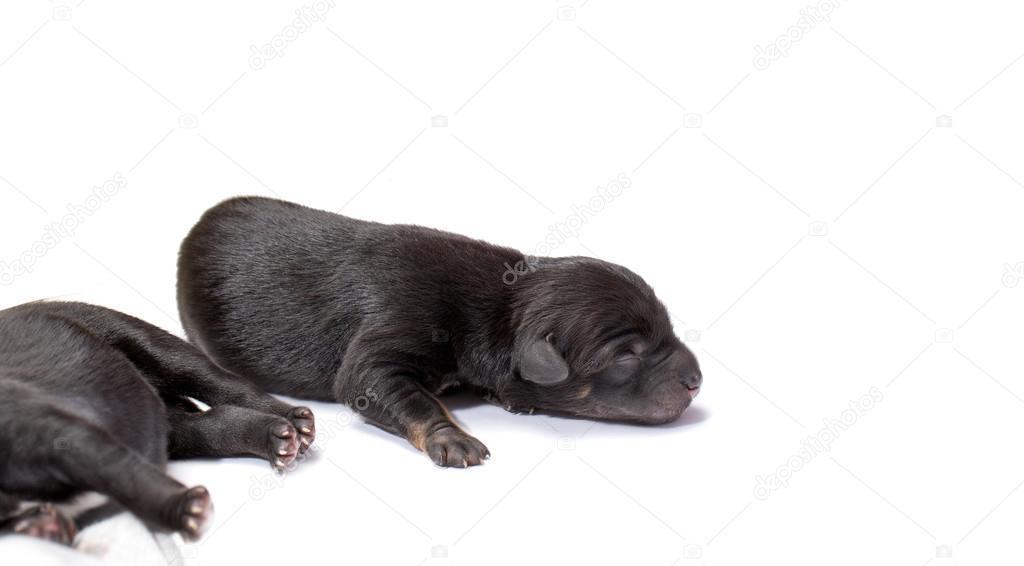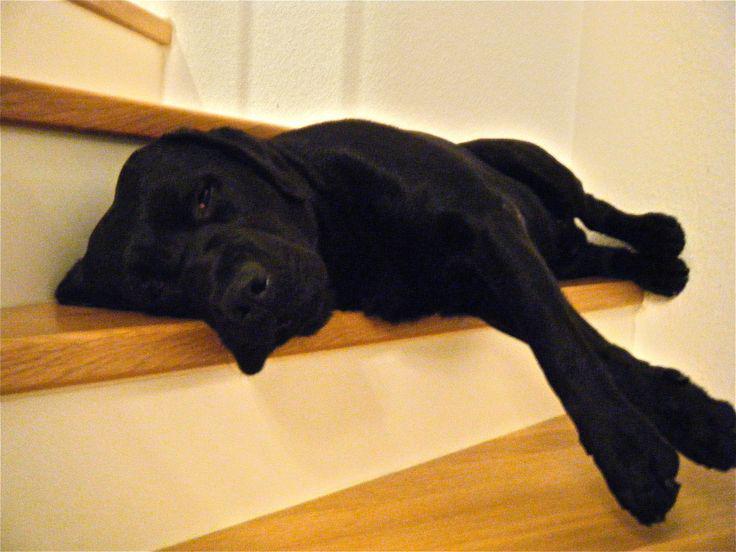The first image is the image on the left, the second image is the image on the right. Analyze the images presented: Is the assertion "A single dog is sleeping in each of the pictures." valid? Answer yes or no. No. The first image is the image on the left, the second image is the image on the right. For the images displayed, is the sentence "Each image shows one sleeping dog, and each dog is sleeping with its head facing the camera and rightside-up." factually correct? Answer yes or no. No. 